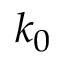<formula> <loc_0><loc_0><loc_500><loc_500>k _ { 0 }</formula> 